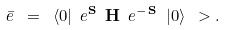Convert formula to latex. <formula><loc_0><loc_0><loc_500><loc_500>\bar { e } \ = \ \langle 0 | \ e ^ { \mathbf S } \ { \mathbf H } \ e ^ { - \, { \mathbf S } } \ | 0 \rangle \ > .</formula> 